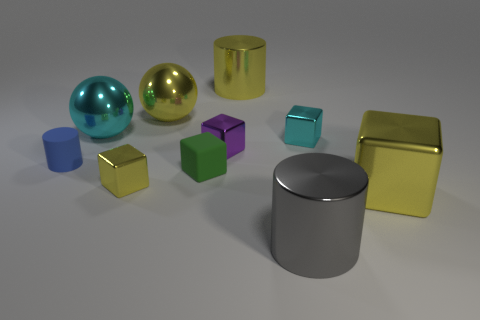There is a tiny metallic cube in front of the small blue thing; is its color the same as the small cylinder? The color of the tiny metallic cube is not the same as the small cylinder. The cube has a golden hue, while the cylinder is silver, reflecting different tones when struck by light. 